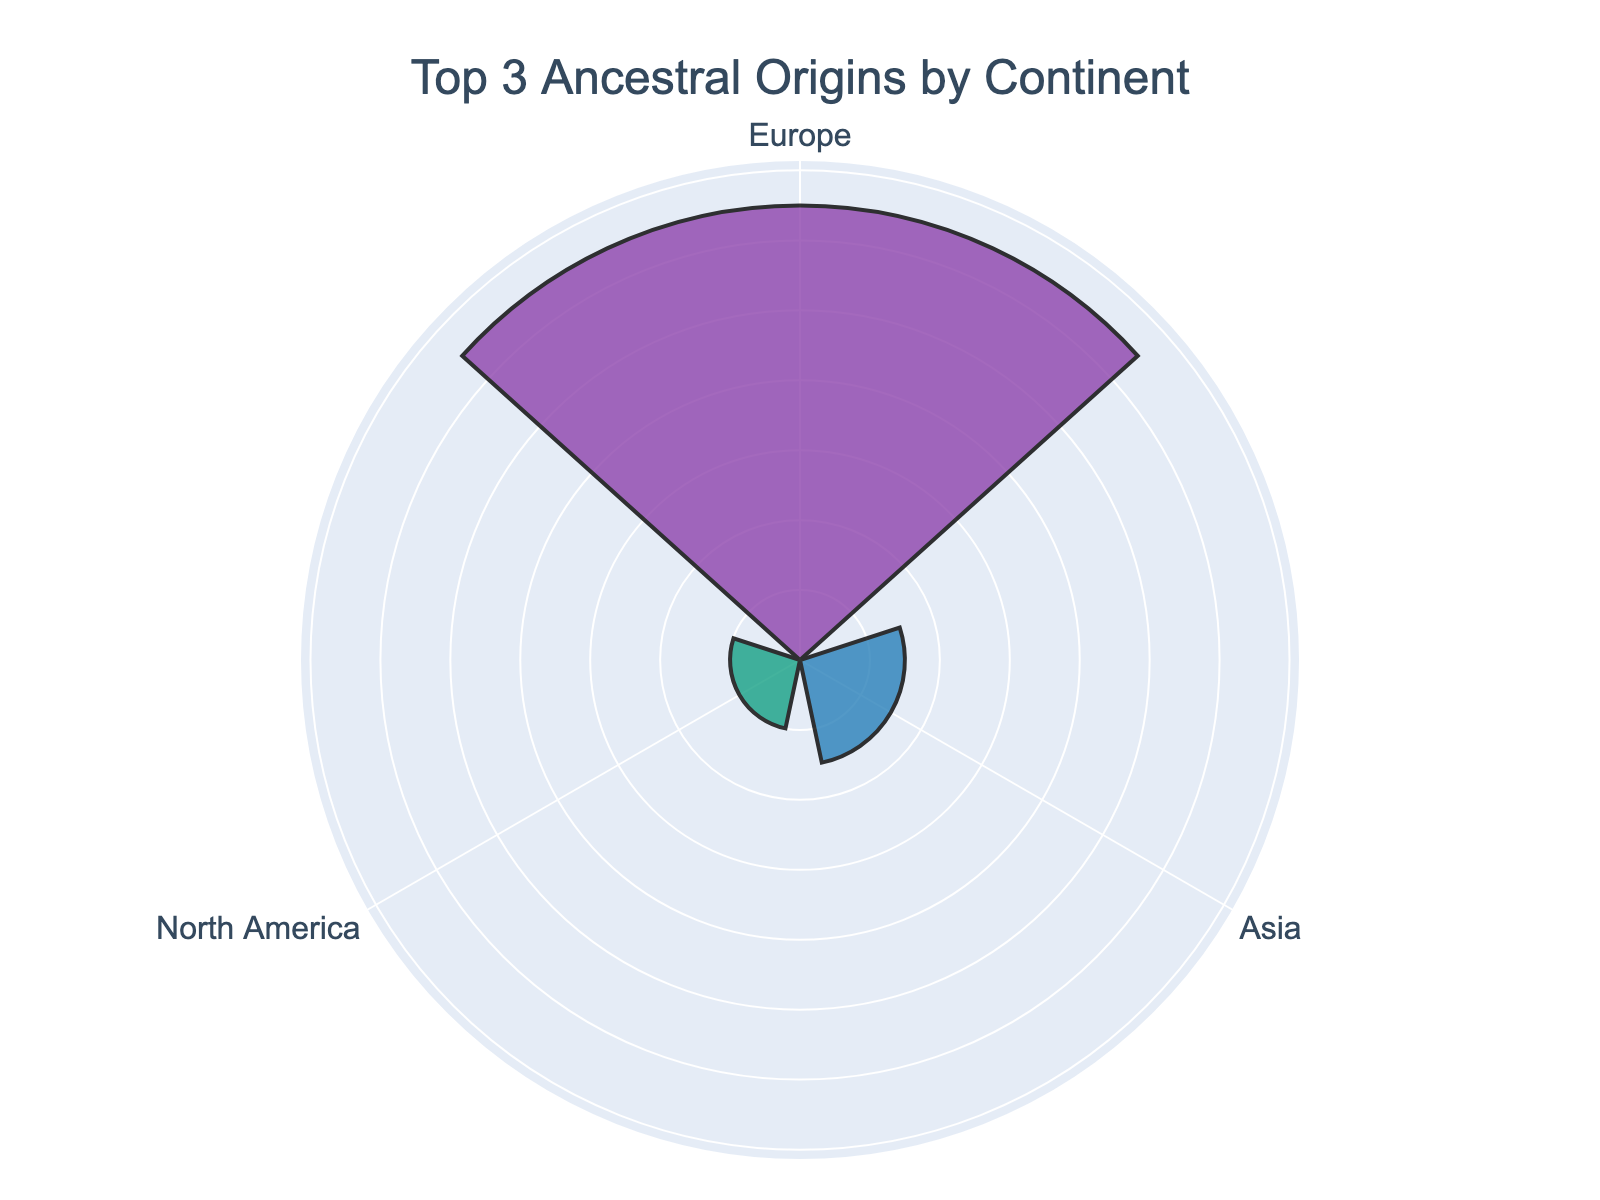What is the title of the figure? The title is usually placed at the top of the chart. In this case, it reads "Top 3 Ancestral Origins by Continent" as per the layout specifications.
Answer: Top 3 Ancestral Origins by Continent Which continent has the highest percentage of ancestral origins? By looking at the lengths of the bars on the rose chart, the one with the longest bar has the highest percentage. According to the provided data, this is Europe.
Answer: Europe What percentage of ancestral origins is assigned to North America on the chart? The rose chart only displays the top 3 continents. Since North America is not among these, its percentage of 10% is not shown in the plot.
Answer: Not displayed What is the combined percentage of ancestral origins from Asia and Africa? According to the provided data, Asia has 15% and Africa has 10%. Adding these together (15% + 10%) gives the combined percentage.
Answer: 25% What is the least represented continent among the top 3 in the rose chart? To find the least represented continent, look for the shortest bar among the top 3 displayed in the rose chart. This is Africa at 10%.
Answer: Africa How much greater is the percentage of ancestral origins for Europe compared to Asia? Europe has 65% and Asia has 15%. Subtracting Asia’s percentage from Europe’s (65% - 15%) gives the difference.
Answer: 50% Which continents are shown in the rose chart? The rose chart shows the top 3 continents based on their percentages. From the provided data, these are Europe, Asia, and Africa.
Answer: Europe, Asia, Africa What color represents the ancestry percentage for Asia? The rose chart uses custom colors for representation. According to the code, the second color (Asia, 15%) is blue.
Answer: Blue If Europe has a percentage of 65%, what is its corresponding percentage beyond 60% on the chart? To find the percentage beyond 60%, subtract 60% from Europe's total of 65% (65% - 60%). This gives 5%.
Answer: 5% Will increasing the percentage of North America to 20% change the continents displayed in the rose chart? Currently, North America's percentage is 10%, below Africa's 10%. Increasing it to 20% would place it in the top 3, likely replacing Africa in the display.
Answer: Yes 